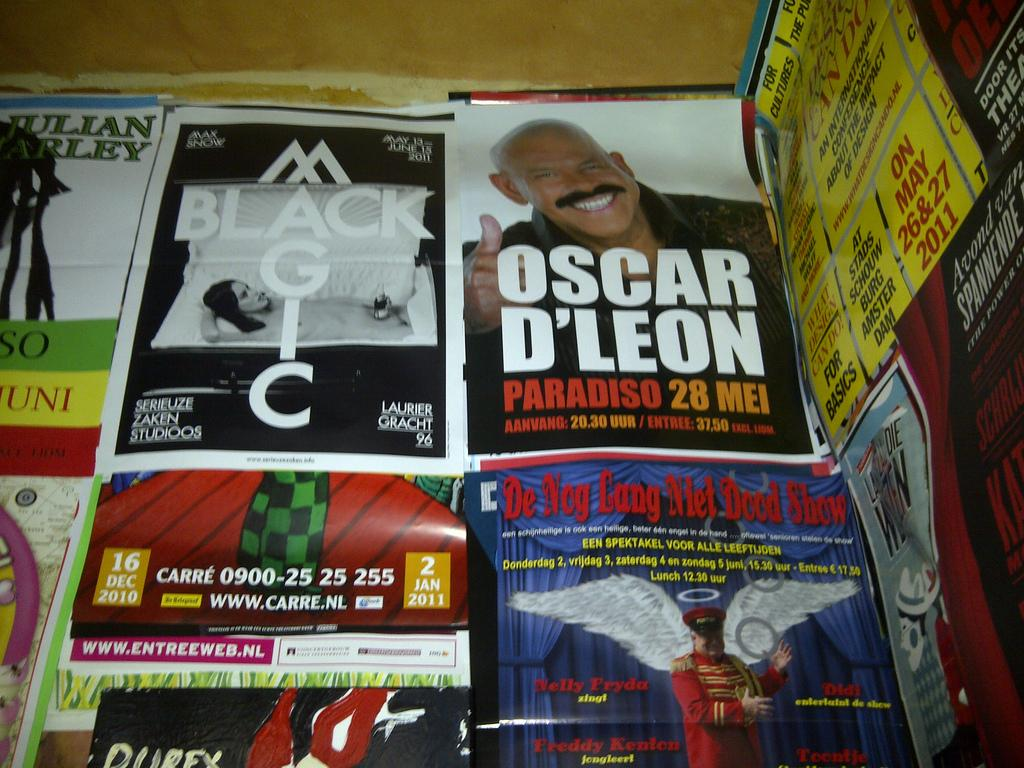<image>
Create a compact narrative representing the image presented. A collection of flyers includes an advertisement for Oscar D'Leon. 